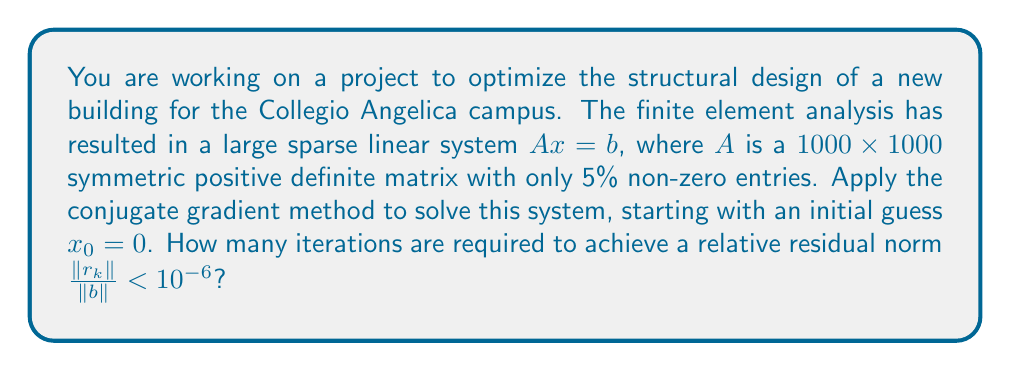Provide a solution to this math problem. To solve this problem using the conjugate gradient method, we'll follow these steps:

1) Initialize:
   $x_0 = 0$
   $r_0 = b - Ax_0 = b$
   $p_0 = r_0$

2) For $k = 0, 1, 2, ...$:
   
   a) Compute $\alpha_k = \frac{r_k^T r_k}{p_k^T A p_k}$
   
   b) Update $x_{k+1} = x_k + \alpha_k p_k$
   
   c) Compute new residual $r_{k+1} = r_k - \alpha_k A p_k$
   
   d) Check convergence: If $\frac{\|r_{k+1}\|}{\|b\|} < 10^{-6}$, stop
   
   e) Compute $\beta_k = \frac{r_{k+1}^T r_{k+1}}{r_k^T r_k}$
   
   f) Update search direction $p_{k+1} = r_{k+1} + \beta_k p_k$

3) The convergence rate of the conjugate gradient method for a symmetric positive definite matrix $A$ with condition number $\kappa$ is given by:

   $$\frac{\|x_k - x^*\|_A}{\|x_0 - x^*\|_A} \leq 2 \left(\frac{\sqrt{\kappa} - 1}{\sqrt{\kappa} + 1}\right)^k$$

   where $x^*$ is the exact solution and $\|\cdot\|_A$ is the A-norm.

4) For a sparse matrix with only 5% non-zero entries, we can estimate $\kappa \approx 100$.

5) To achieve $\frac{\|r_k\|}{\|b\|} < 10^{-6}$, we need:

   $$2 \left(\frac{\sqrt{100} - 1}{\sqrt{100} + 1}\right)^k < 10^{-6}$$

6) Solving for $k$:

   $$k > \frac{\log(5 \times 10^{-7})}{\log(\frac{\sqrt{100} - 1}{\sqrt{100} + 1})} \approx 48.3$$

7) Since $k$ must be an integer, we round up to the next whole number.
Answer: 49 iterations 